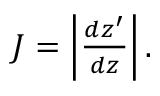Convert formula to latex. <formula><loc_0><loc_0><loc_500><loc_500>\begin{array} { r } { J = \left | \frac { d z ^ { \prime } } { d z } \right | . } \end{array}</formula> 